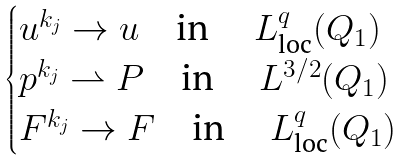<formula> <loc_0><loc_0><loc_500><loc_500>\begin{cases} u ^ { k _ { j } } \rightarrow u \quad \text {in } \quad L ^ { q } _ { \text {loc} } ( Q _ { 1 } ) \\ p ^ { k _ { j } } \rightharpoonup P \quad \text {in } \quad L ^ { 3 / 2 } ( Q _ { 1 } ) \\ F ^ { k _ { j } } \rightarrow F \quad \text {in } \quad L ^ { q } _ { \text {loc} } ( Q _ { 1 } ) \end{cases}</formula> 